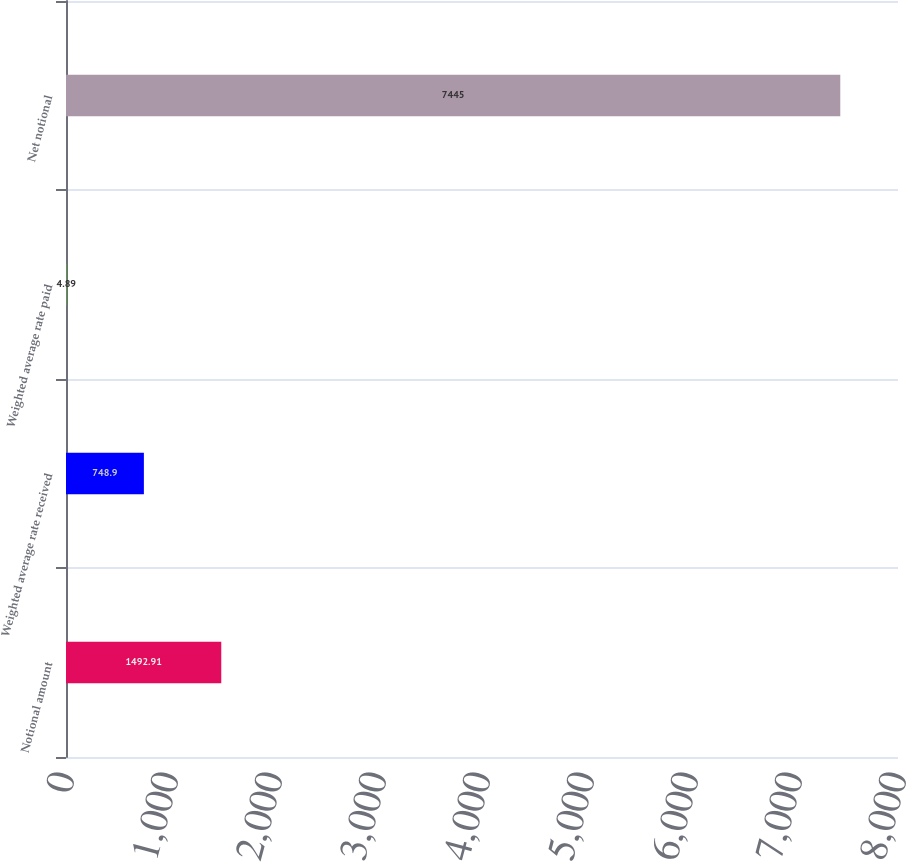Convert chart to OTSL. <chart><loc_0><loc_0><loc_500><loc_500><bar_chart><fcel>Notional amount<fcel>Weighted average rate received<fcel>Weighted average rate paid<fcel>Net notional<nl><fcel>1492.91<fcel>748.9<fcel>4.89<fcel>7445<nl></chart> 